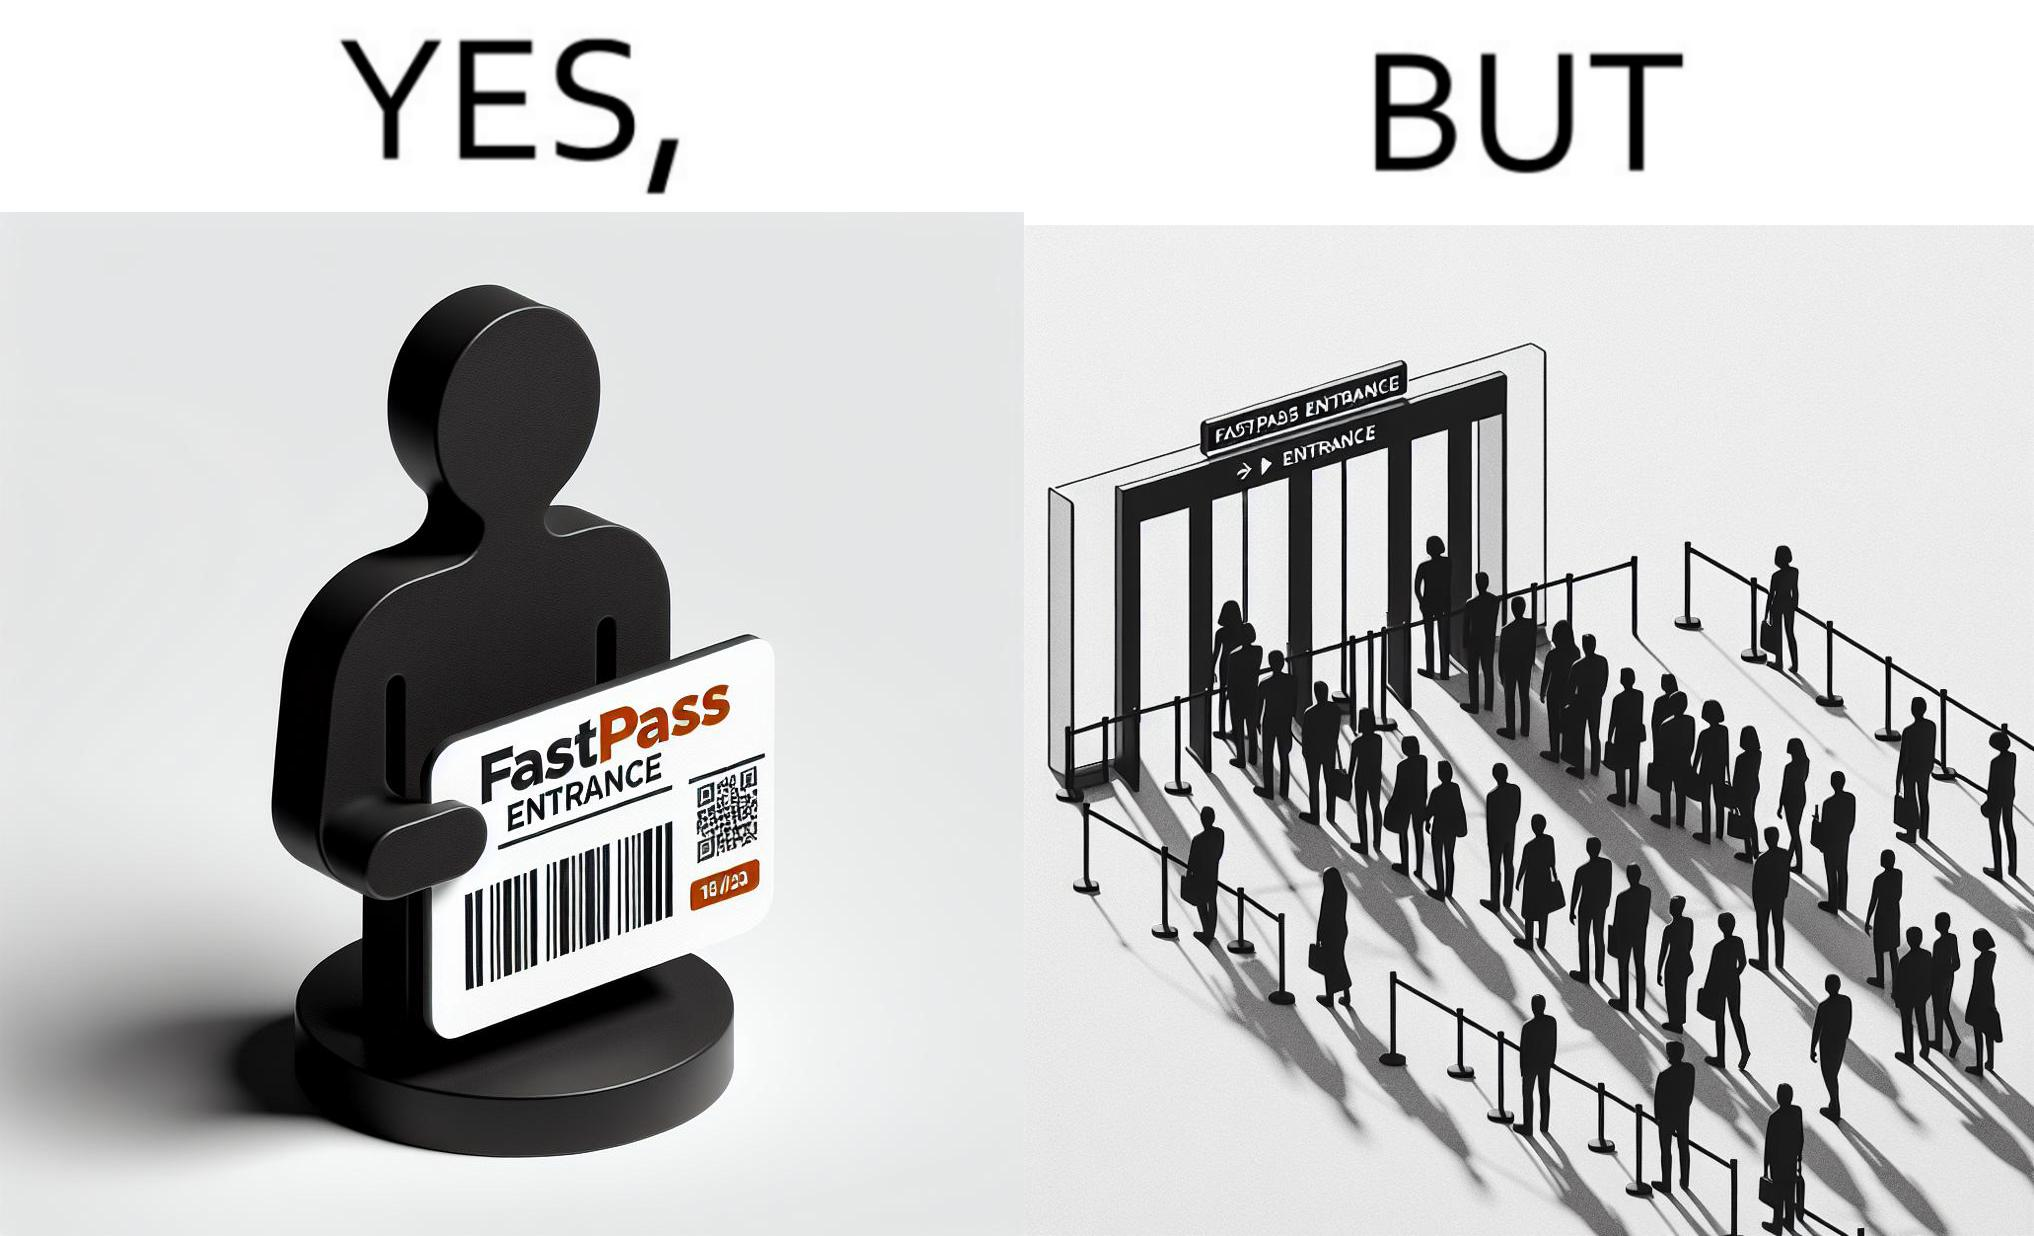Describe the contrast between the left and right parts of this image. In the left part of the image: a person holding a "FASTPASS ENTRANCE" ticket or token of date "15/05/23" with some barcode In the right part of the image: people in a long queue in front of "FASTPASS ENTRANCE"  gate and "ENTRANCE" gate is vacant without any queue 